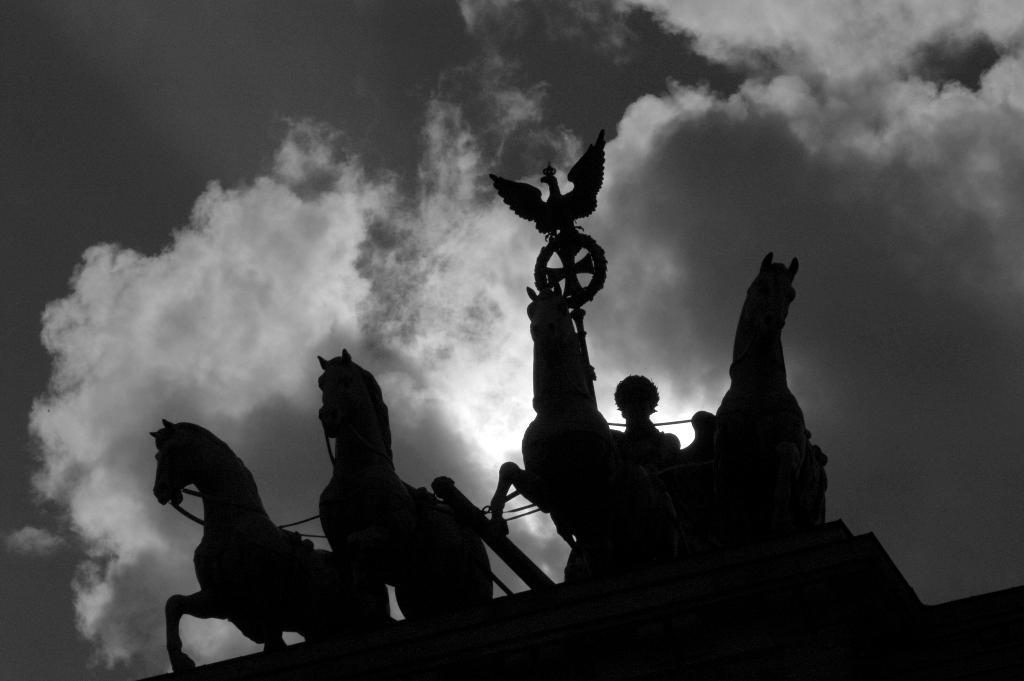What type of art is featured in the image? There are sculptures in the image. Where are the sculptures located in the image? The sculptures are in the front of the image. What can be seen in the background of the image? There are clouds in the background of the image. What is the color scheme of the image? The image is black and white in color. What type of produce can be seen growing in the image? There is no produce visible in the image; it features sculptures and clouds. Is there a cave present in the image? There is no cave present in the image. 